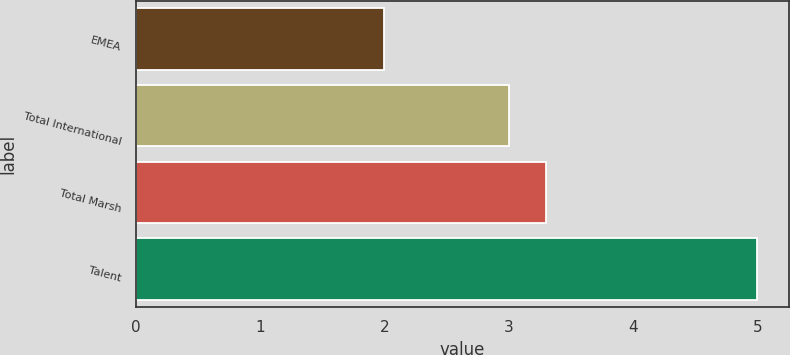Convert chart. <chart><loc_0><loc_0><loc_500><loc_500><bar_chart><fcel>EMEA<fcel>Total International<fcel>Total Marsh<fcel>Talent<nl><fcel>2<fcel>3<fcel>3.3<fcel>5<nl></chart> 